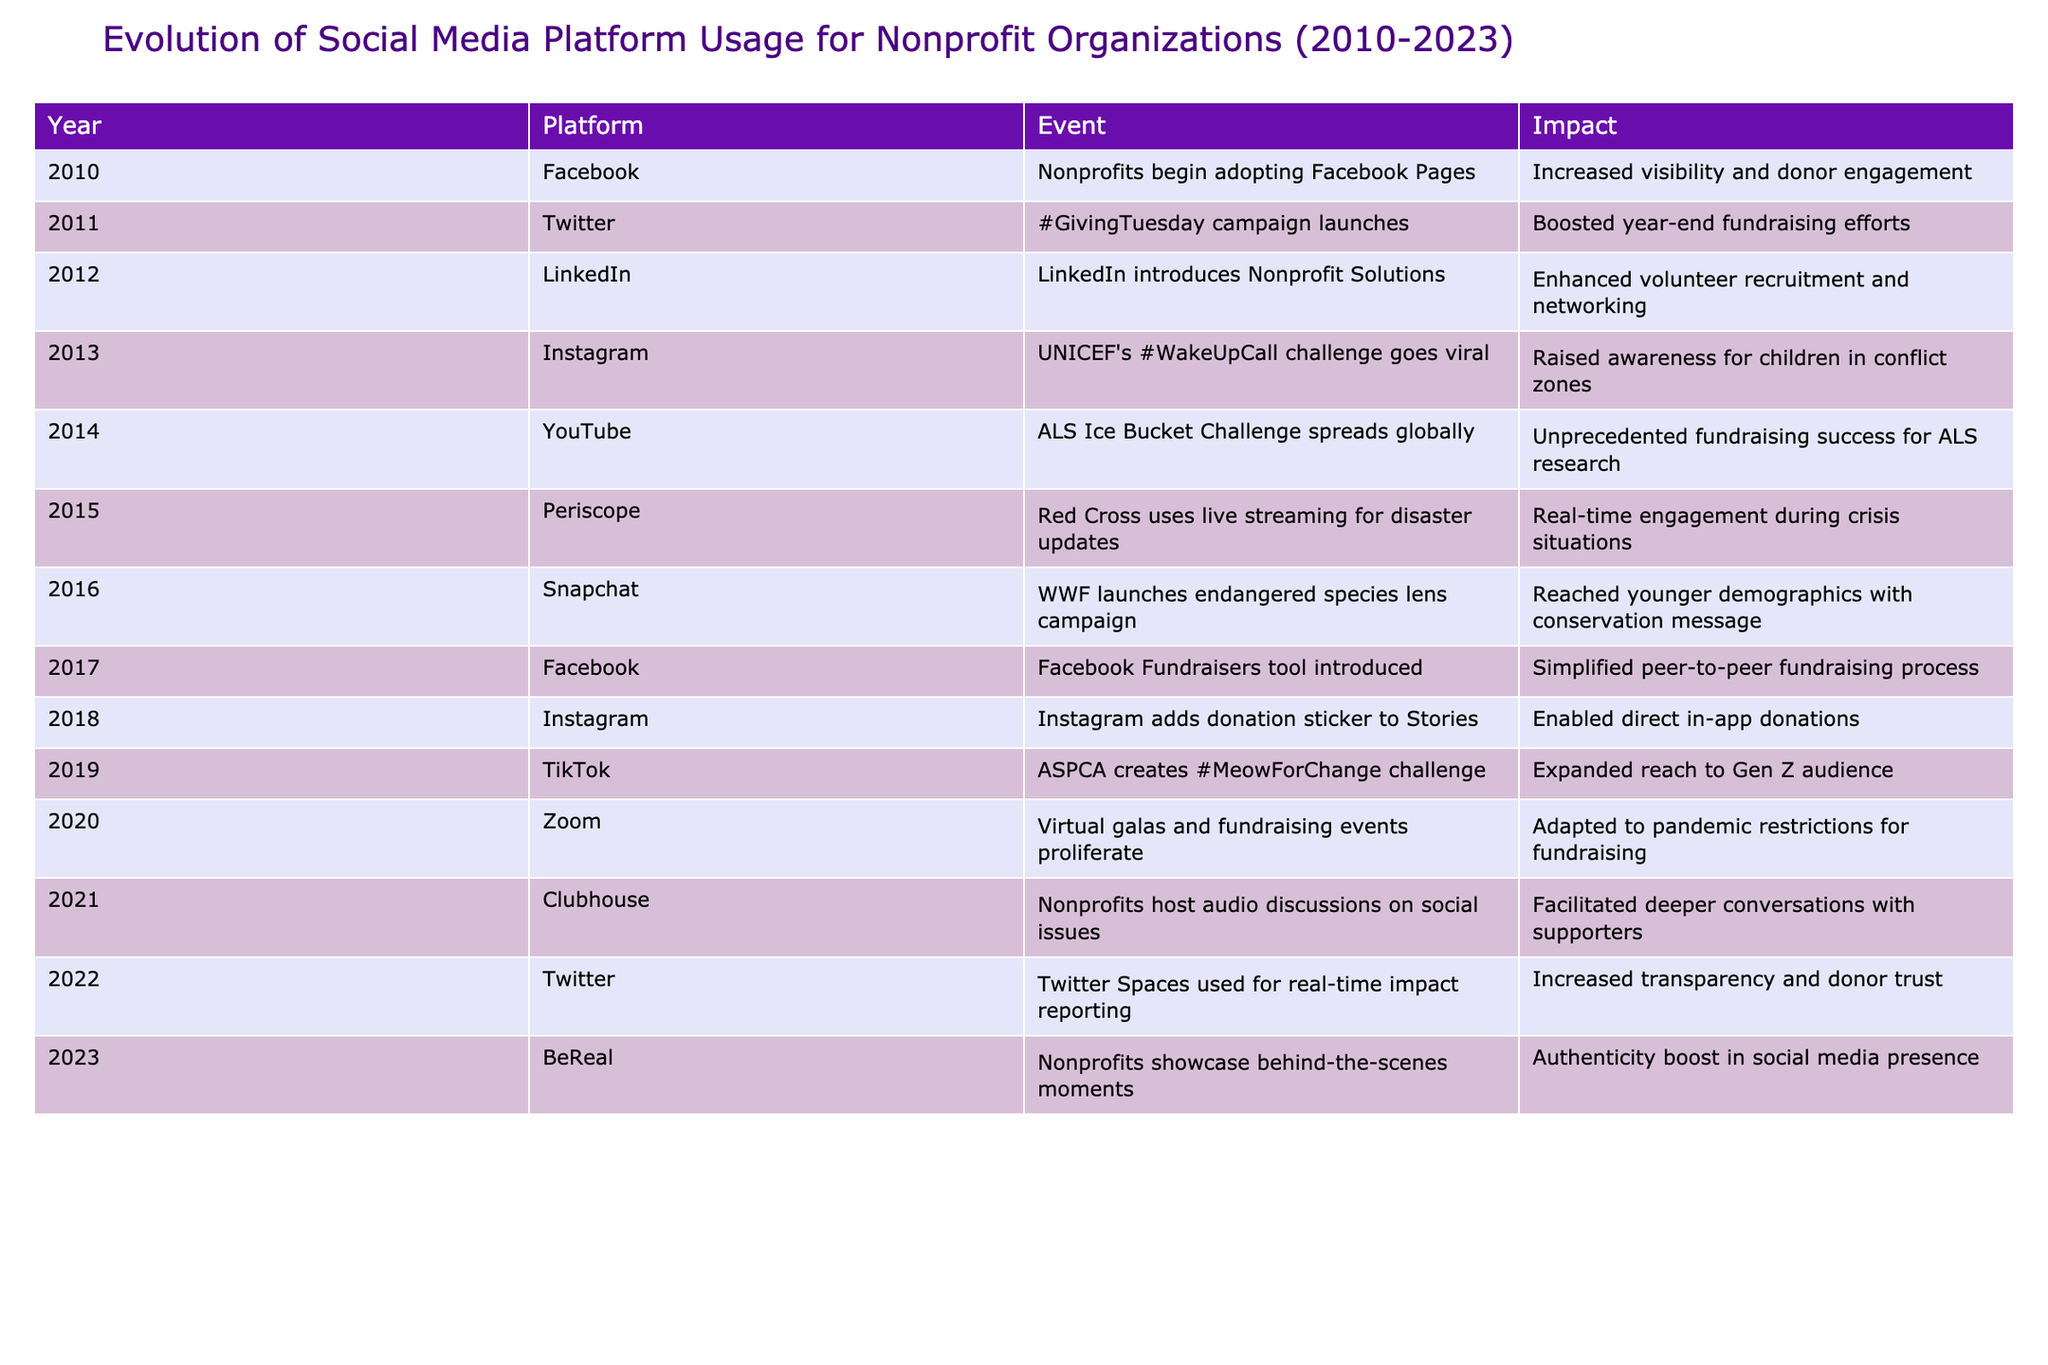What platform did nonprofits first adopt for increased visibility in 2010? The table shows that in 2010, nonprofits began adopting Facebook Pages to enhance their visibility.
Answer: Facebook How did the #GivingTuesday campaign in 2011 impact fundraising efforts? According to the table, the #GivingTuesday campaign launched in 2011 and significantly boosted year-end fundraising efforts for nonprofits.
Answer: Boosted fundraising efforts Which platform was introduced in 2012 specifically for nonprofit solutions? The data shows that LinkedIn introduced Nonprofit Solutions in 2012 to enhance volunteer recruitment and networking.
Answer: LinkedIn What year did nonprofits start using Zoom for fundraising events? From the table, we can see that nonprofits began using Zoom for virtual galas and fundraising events in 2020, particularly in response to pandemic restrictions.
Answer: 2020 Which platform saw the introduction of a donation sticker in 2018? The table indicates that Instagram added a donation sticker to Stories in 2018, allowing nonprofits to enable direct in-app donations.
Answer: Instagram In which year did the ALS Ice Bucket Challenge lead to unprecedented fundraising success? The table states that the ALS Ice Bucket Challenge spread globally in 2014, leading to unprecedented fundraising success for ALS research.
Answer: 2014 Did Twitter introduce any tools for nonprofits before 2020? According to the table, Twitter was used for the #GivingTuesday campaign in 2011 and introduced Twitter Spaces for impact reporting in 2022, indicating that Twitter had supportive initiatives for nonprofits before 2020.
Answer: Yes Which two platforms introduced tools or features for fundraising and donation purposes between 2017 and 2019? Looking at the table, Facebook introduced the Fundraisers tool in 2017, and Instagram added the donation sticker in 2018, both aimed at supporting fundraising for nonprofits.
Answer: Facebook and Instagram How did the introduction of the BeReal platform in 2023 impact nonprofit organizations? The data reveals that BeReal allowed nonprofits to showcase behind-the-scenes moments, which contributed to an authenticity boost in their social media presence in 2023.
Answer: Authenticity boost What has been the trend in social media platform usage for nonprofits from 2010 to 2023? Analyzing the table, the trend shows a progression from basic presence on platforms like Facebook to more interactive and engaging features like donation stickers, live streaming, and real-time discussions, reflecting a growing emphasis on engagement and innovation in fundraising efforts.
Answer: Increasing engagement and innovation in fundraising 